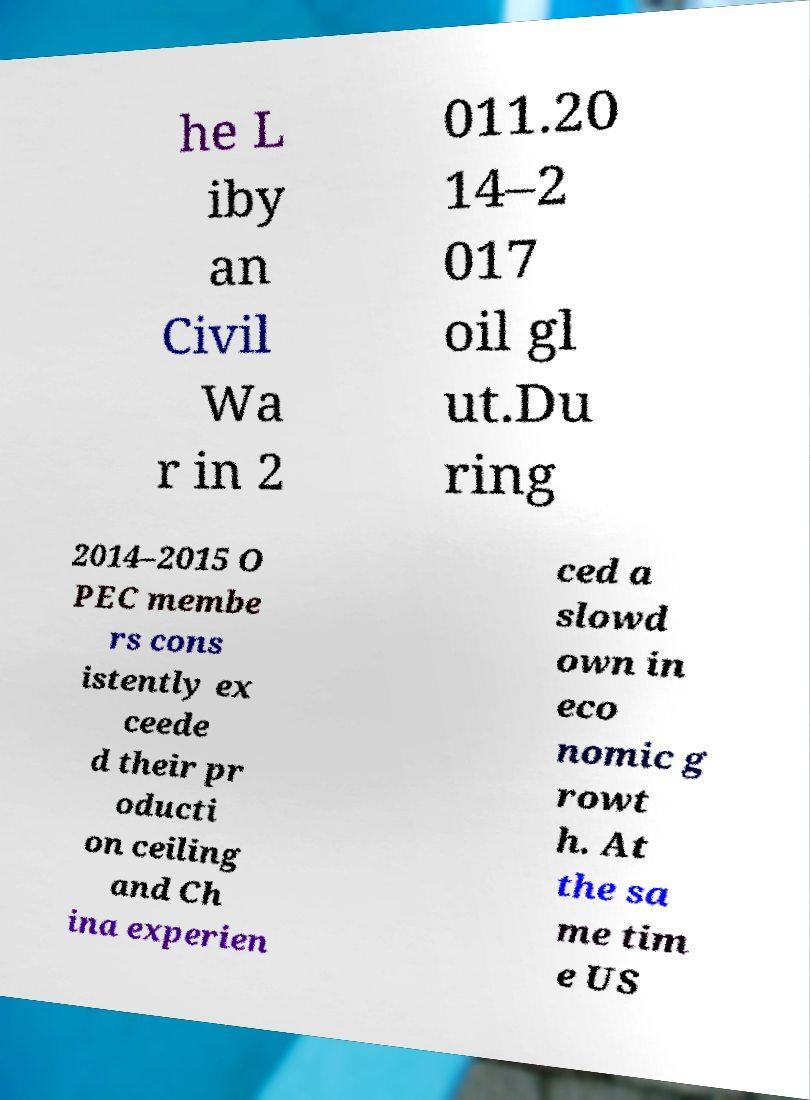Please read and relay the text visible in this image. What does it say? he L iby an Civil Wa r in 2 011.20 14–2 017 oil gl ut.Du ring 2014–2015 O PEC membe rs cons istently ex ceede d their pr oducti on ceiling and Ch ina experien ced a slowd own in eco nomic g rowt h. At the sa me tim e US 